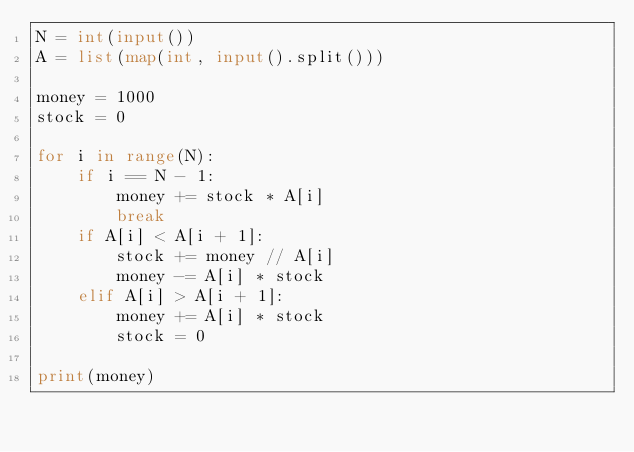Convert code to text. <code><loc_0><loc_0><loc_500><loc_500><_Python_>N = int(input())
A = list(map(int, input().split()))

money = 1000
stock = 0

for i in range(N):
    if i == N - 1:
        money += stock * A[i]
        break
    if A[i] < A[i + 1]:
        stock += money // A[i]
        money -= A[i] * stock
    elif A[i] > A[i + 1]:
        money += A[i] * stock
        stock = 0

print(money)
</code> 